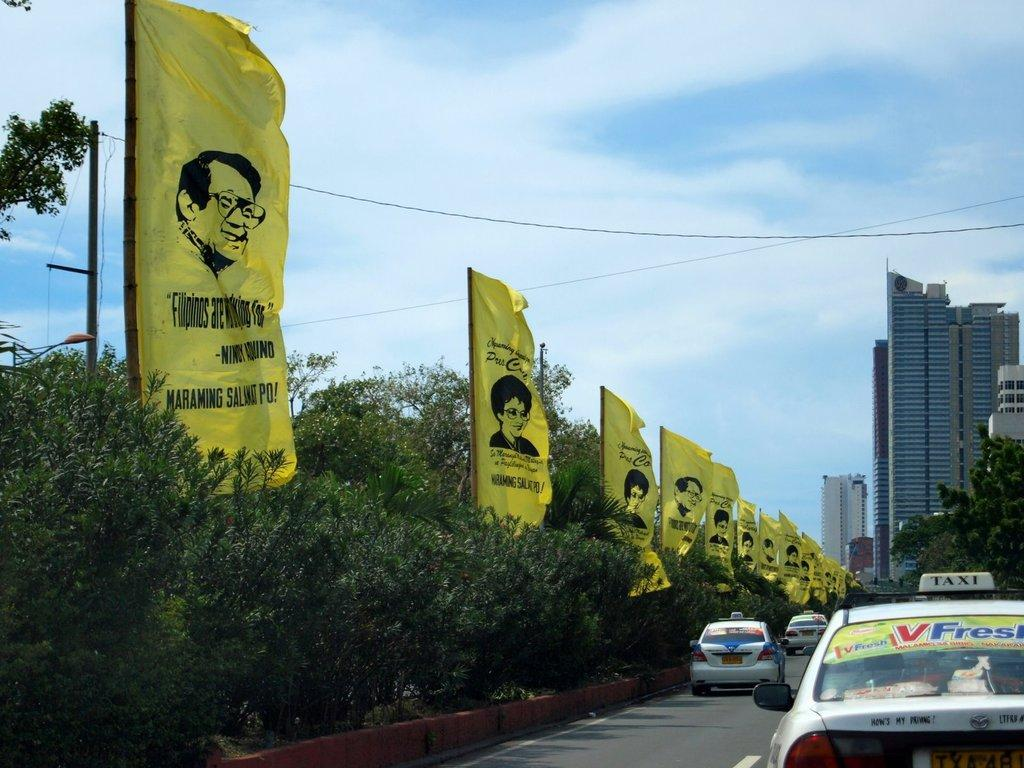<image>
Write a terse but informative summary of the picture. The first yellow poster is about filipinos asking for something. 